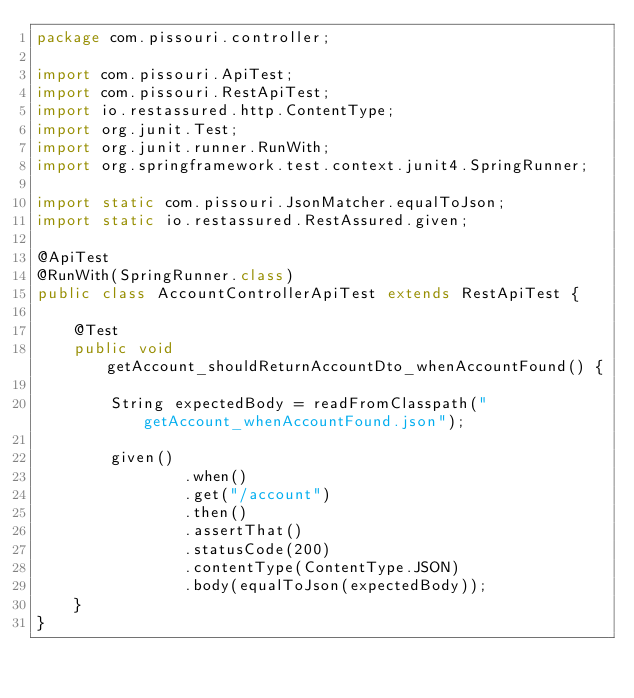<code> <loc_0><loc_0><loc_500><loc_500><_Java_>package com.pissouri.controller;

import com.pissouri.ApiTest;
import com.pissouri.RestApiTest;
import io.restassured.http.ContentType;
import org.junit.Test;
import org.junit.runner.RunWith;
import org.springframework.test.context.junit4.SpringRunner;

import static com.pissouri.JsonMatcher.equalToJson;
import static io.restassured.RestAssured.given;

@ApiTest
@RunWith(SpringRunner.class)
public class AccountControllerApiTest extends RestApiTest {

    @Test
    public void getAccount_shouldReturnAccountDto_whenAccountFound() {

        String expectedBody = readFromClasspath("getAccount_whenAccountFound.json");

        given()
                .when()
                .get("/account")
                .then()
                .assertThat()
                .statusCode(200)
                .contentType(ContentType.JSON)
                .body(equalToJson(expectedBody));
    }
}</code> 